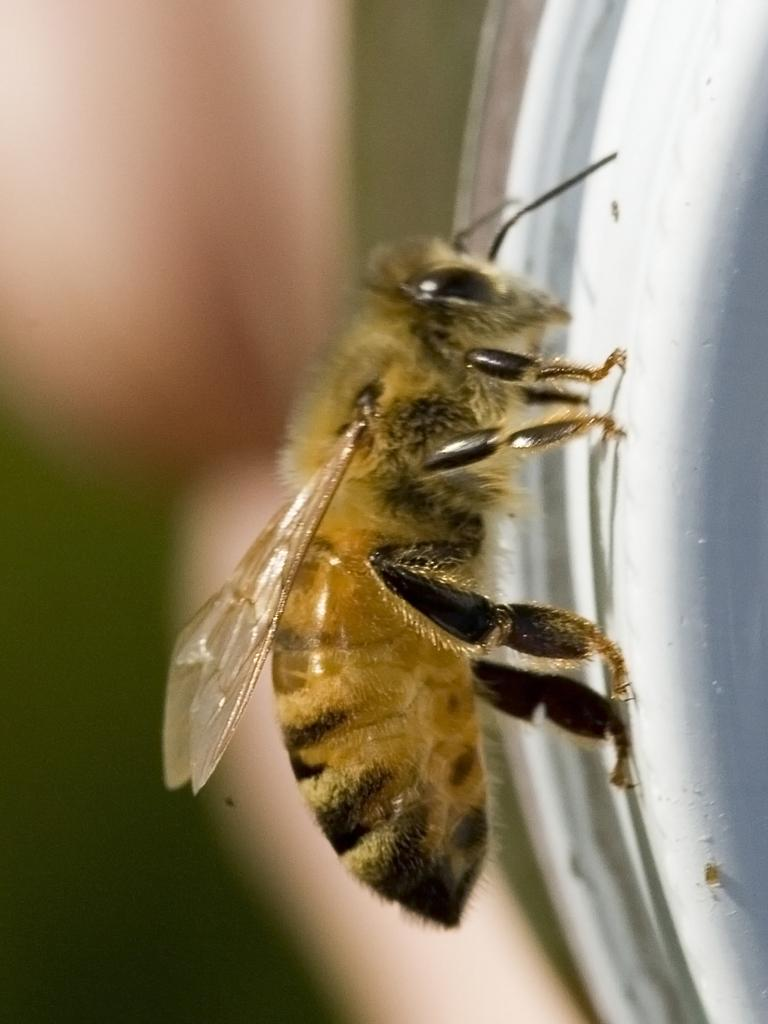What type of creature is present in the image? There is an insect in the image. How is the background of the image depicted? The background of the insect is blurred. What shape is the thumb of the insect in the image? There is no thumb present in the image, as the subject is an insect, not a human. 